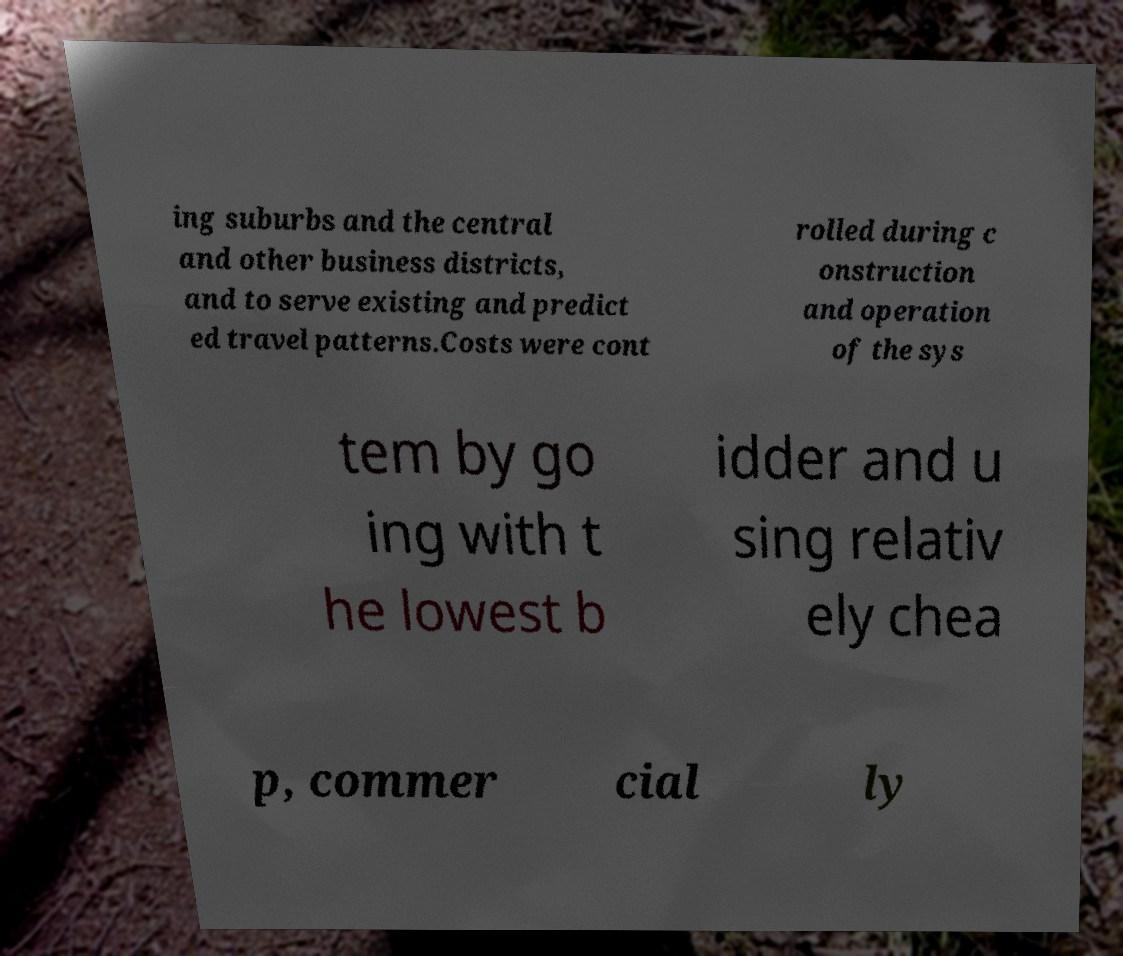There's text embedded in this image that I need extracted. Can you transcribe it verbatim? ing suburbs and the central and other business districts, and to serve existing and predict ed travel patterns.Costs were cont rolled during c onstruction and operation of the sys tem by go ing with t he lowest b idder and u sing relativ ely chea p, commer cial ly 